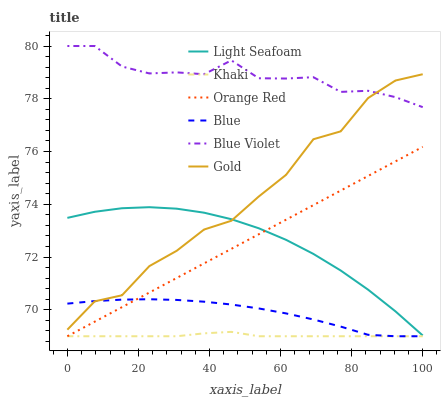Does Gold have the minimum area under the curve?
Answer yes or no. No. Does Gold have the maximum area under the curve?
Answer yes or no. No. Is Khaki the smoothest?
Answer yes or no. No. Is Khaki the roughest?
Answer yes or no. No. Does Gold have the lowest value?
Answer yes or no. No. Does Gold have the highest value?
Answer yes or no. No. Is Khaki less than Blue Violet?
Answer yes or no. Yes. Is Gold greater than Orange Red?
Answer yes or no. Yes. Does Khaki intersect Blue Violet?
Answer yes or no. No. 